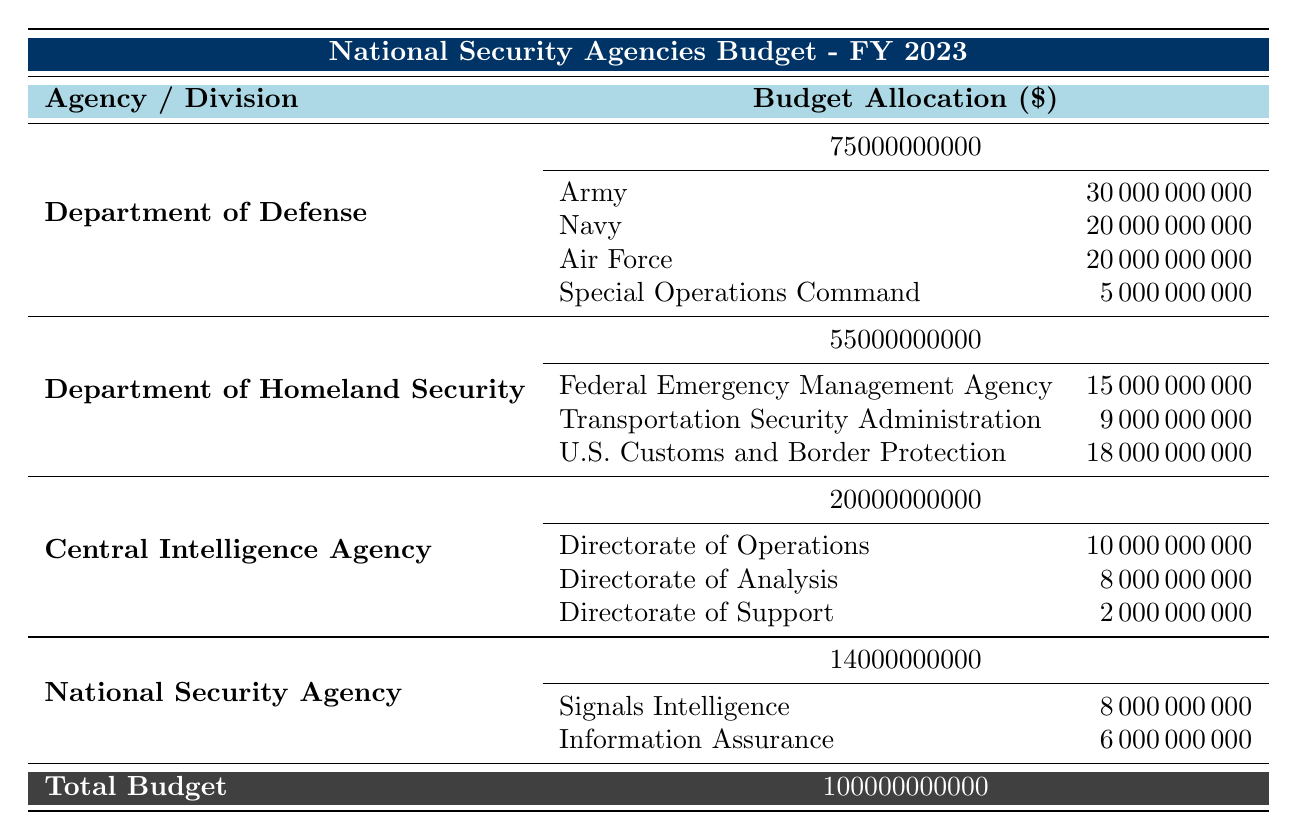What is the total budget allocation for the Department of Defense? The table shows the budget allocation for the Department of Defense as 75,000,000,000.
Answer: 75,000,000,000 How much budget does the U.S. Customs and Border Protection receive? From the table, the budget allocated to U.S. Customs and Border Protection is 18,000,000,000.
Answer: 18,000,000,000 What is the combined budget for the Army and Navy? The budget for the Army is 30,000,000,000 and for the Navy is 20,000,000,000. So, the combined budget is 30,000,000,000 + 20,000,000,000 = 50,000,000,000.
Answer: 50,000,000,000 Is the budget for the Federal Emergency Management Agency greater than that of the Transportation Security Administration? The budget for the Federal Emergency Management Agency is 15,000,000,000 and for the Transportation Security Administration is 9,000,000,000. Since 15,000,000,000 is greater than 9,000,000,000, the statement is true.
Answer: Yes What agency has the smallest budget allocation, and what is that amount? The Central Intelligence Agency has a budget allocation of 20,000,000,000, the National Security Agency has 14,000,000,000, and the others have higher amounts. Therefore, the National Security Agency has the smallest amount, which is 14,000,000,000.
Answer: National Security Agency, 14,000,000,000 What is the difference between the budget of the Department of Homeland Security and the Central Intelligence Agency? The Department of Homeland Security has a budget allocation of 55,000,000,000 and the Central Intelligence Agency has 20,000,000,000. The difference is 55,000,000,000 - 20,000,000,000 = 35,000,000,000.
Answer: 35,000,000,000 What percentage of the total budget is allocated to the Army? The Army's budget is 30,000,000,000. The total budget is 100,000,000,000. The percentage is calculated as (30,000,000,000 / 100,000,000,000) * 100, which is 30%.
Answer: 30% How many divisions are under the National Security Agency? The table indicates that there are two divisions under the National Security Agency: Signals Intelligence and Information Assurance.
Answer: 2 What is the total budget allocation for all agencies combined in fiscal year 2023? The total budget allocation provided in the table is explicitly stated as 100,000,000,000, which includes all the agencies collectively.
Answer: 100,000,000,000 How does the budget for the Special Operations Command compare to that of the Directorate of Analysis? The budget for the Special Operations Command is 5,000,000,000, and for the Directorate of Analysis, it is 8,000,000,000. Since 5,000,000,000 is less than 8,000,000,000, the Special Operations Command has a smaller budget.
Answer: Special Operations Command has a smaller budget 